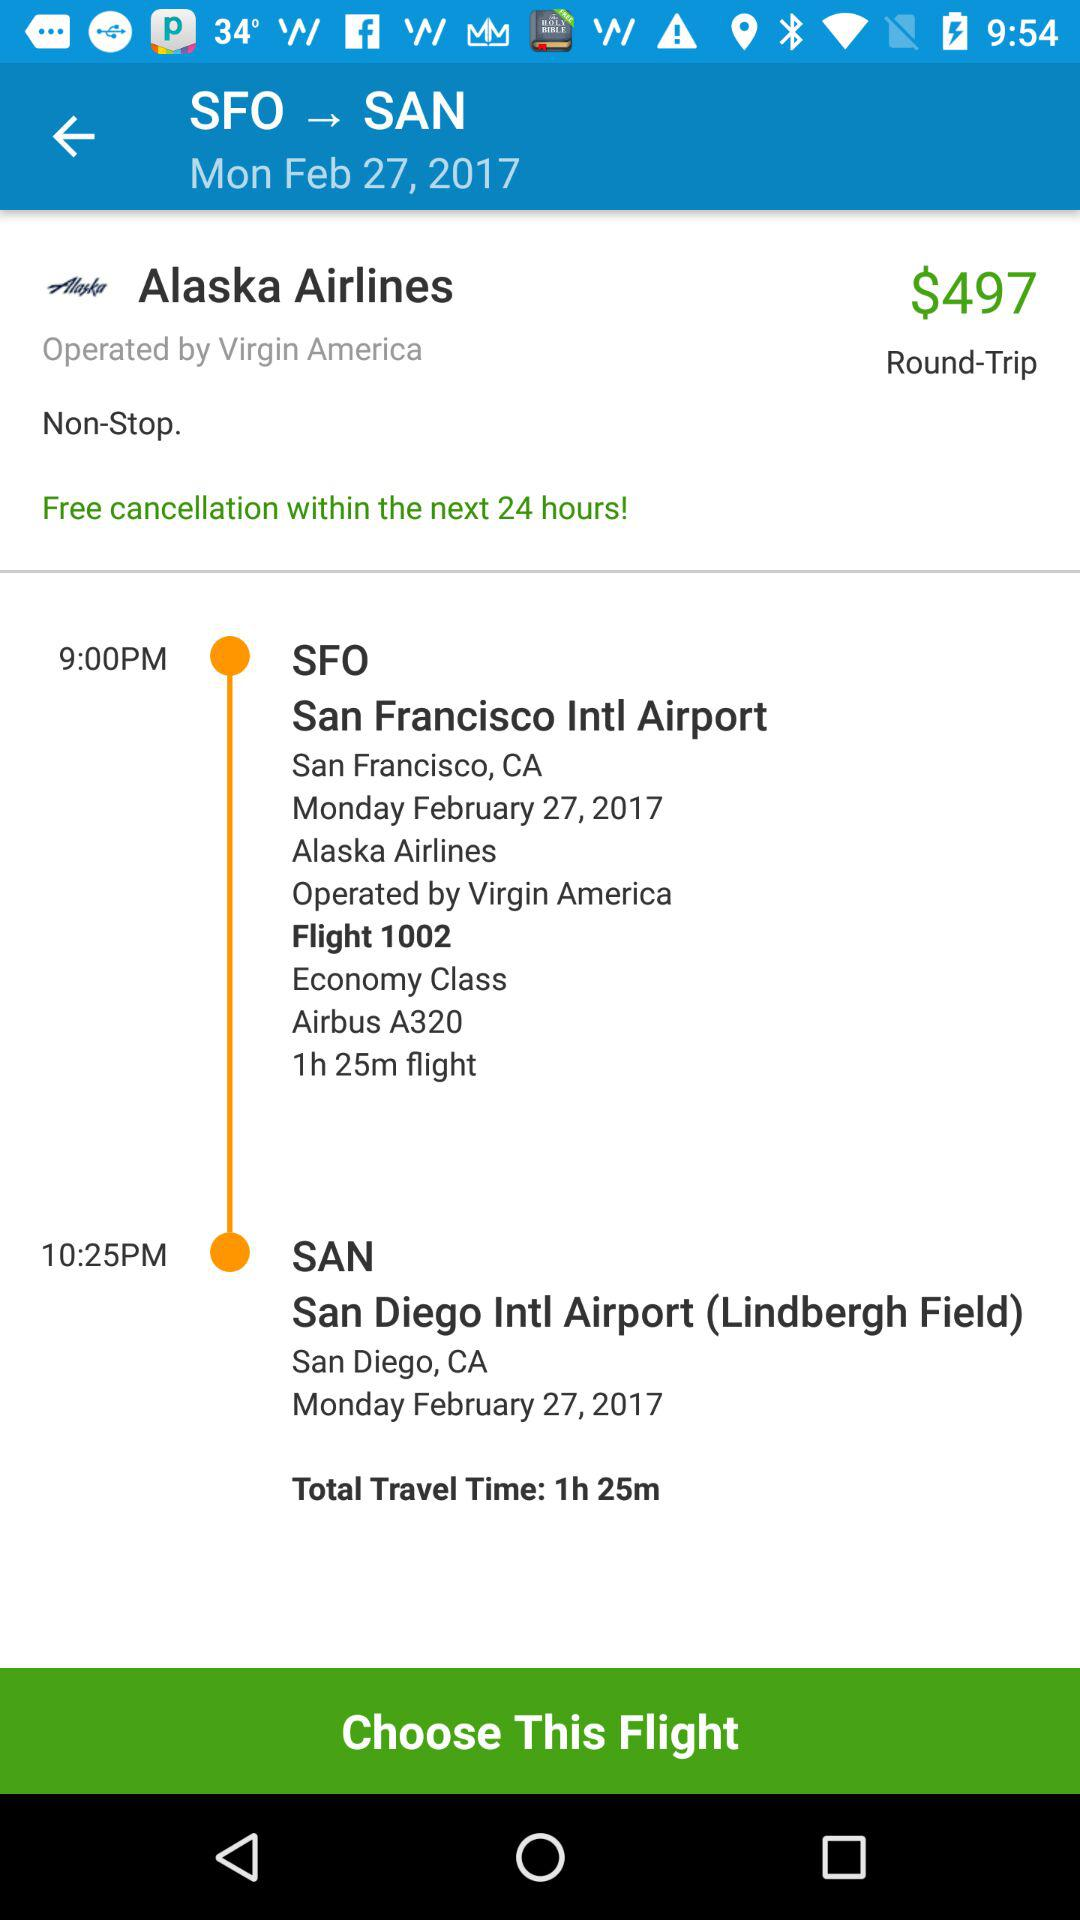Within how many hours free cancellation can be done? Free cancellation can be done within the next 24 hours. 